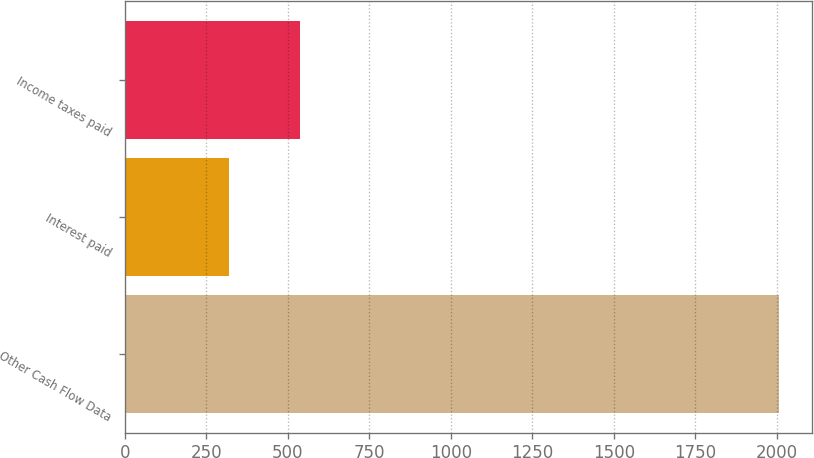<chart> <loc_0><loc_0><loc_500><loc_500><bar_chart><fcel>Other Cash Flow Data<fcel>Interest paid<fcel>Income taxes paid<nl><fcel>2008<fcel>319<fcel>538<nl></chart> 